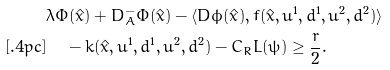Convert formula to latex. <formula><loc_0><loc_0><loc_500><loc_500>& \lambda \Phi ( \hat { x } ) + D _ { A } ^ { - } \Phi ( \hat { x } ) - \langle D \phi ( \hat { x } ) , f ( \hat { x } , u ^ { 1 } , d ^ { 1 } , u ^ { 2 } , d ^ { 2 } ) \rangle \\ [ . 4 p c ] & \quad \, - k ( \hat { x } , u ^ { 1 } , d ^ { 1 } , u ^ { 2 } , d ^ { 2 } ) - C _ { R } L ( \psi ) \geq \frac { r } { 2 } .</formula> 